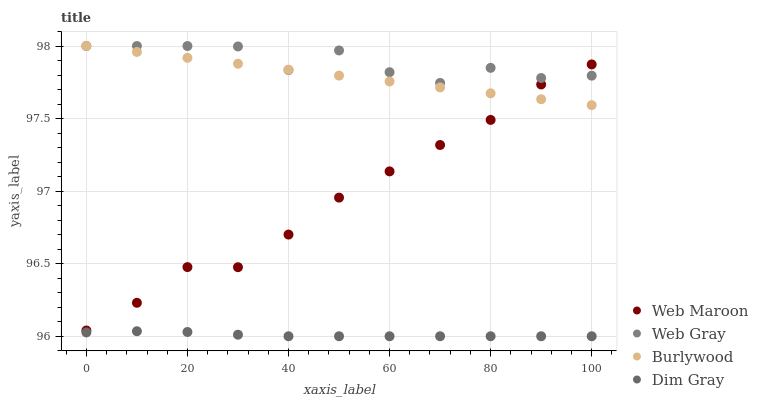Does Dim Gray have the minimum area under the curve?
Answer yes or no. Yes. Does Web Gray have the maximum area under the curve?
Answer yes or no. Yes. Does Web Gray have the minimum area under the curve?
Answer yes or no. No. Does Dim Gray have the maximum area under the curve?
Answer yes or no. No. Is Burlywood the smoothest?
Answer yes or no. Yes. Is Web Gray the roughest?
Answer yes or no. Yes. Is Dim Gray the smoothest?
Answer yes or no. No. Is Dim Gray the roughest?
Answer yes or no. No. Does Dim Gray have the lowest value?
Answer yes or no. Yes. Does Web Gray have the lowest value?
Answer yes or no. No. Does Web Gray have the highest value?
Answer yes or no. Yes. Does Dim Gray have the highest value?
Answer yes or no. No. Is Dim Gray less than Web Gray?
Answer yes or no. Yes. Is Web Gray greater than Dim Gray?
Answer yes or no. Yes. Does Web Maroon intersect Burlywood?
Answer yes or no. Yes. Is Web Maroon less than Burlywood?
Answer yes or no. No. Is Web Maroon greater than Burlywood?
Answer yes or no. No. Does Dim Gray intersect Web Gray?
Answer yes or no. No. 